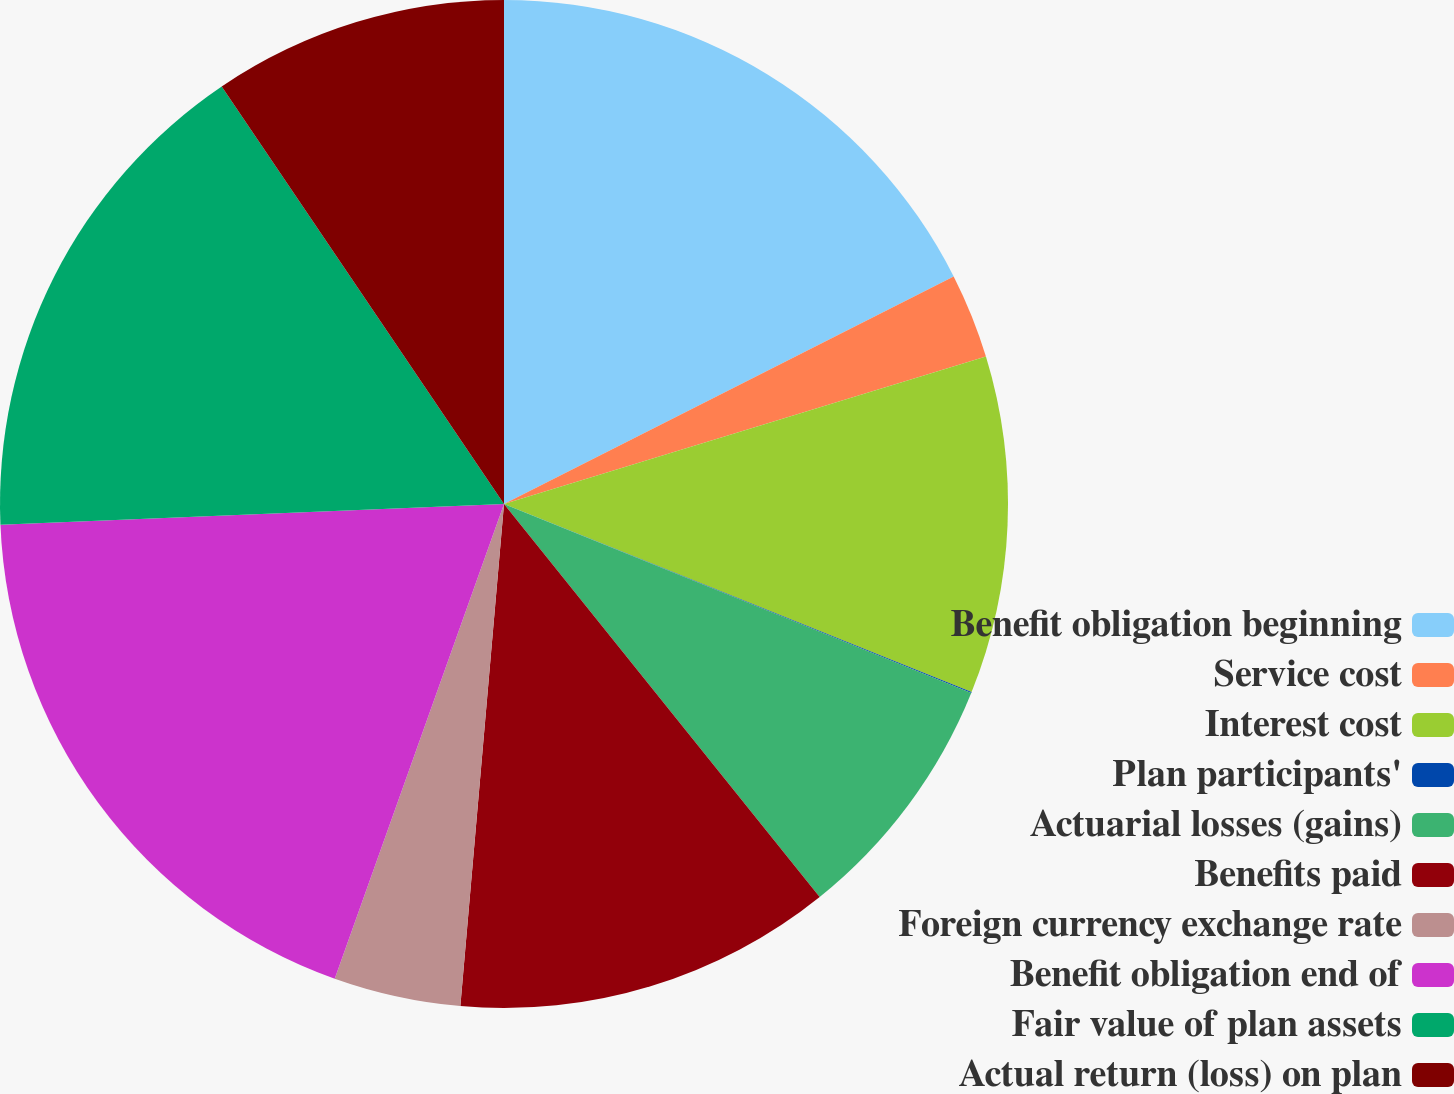<chart> <loc_0><loc_0><loc_500><loc_500><pie_chart><fcel>Benefit obligation beginning<fcel>Service cost<fcel>Interest cost<fcel>Plan participants'<fcel>Actuarial losses (gains)<fcel>Benefits paid<fcel>Foreign currency exchange rate<fcel>Benefit obligation end of<fcel>Fair value of plan assets<fcel>Actual return (loss) on plan<nl><fcel>17.54%<fcel>2.73%<fcel>10.81%<fcel>0.03%<fcel>8.11%<fcel>12.15%<fcel>4.07%<fcel>18.89%<fcel>16.19%<fcel>9.46%<nl></chart> 